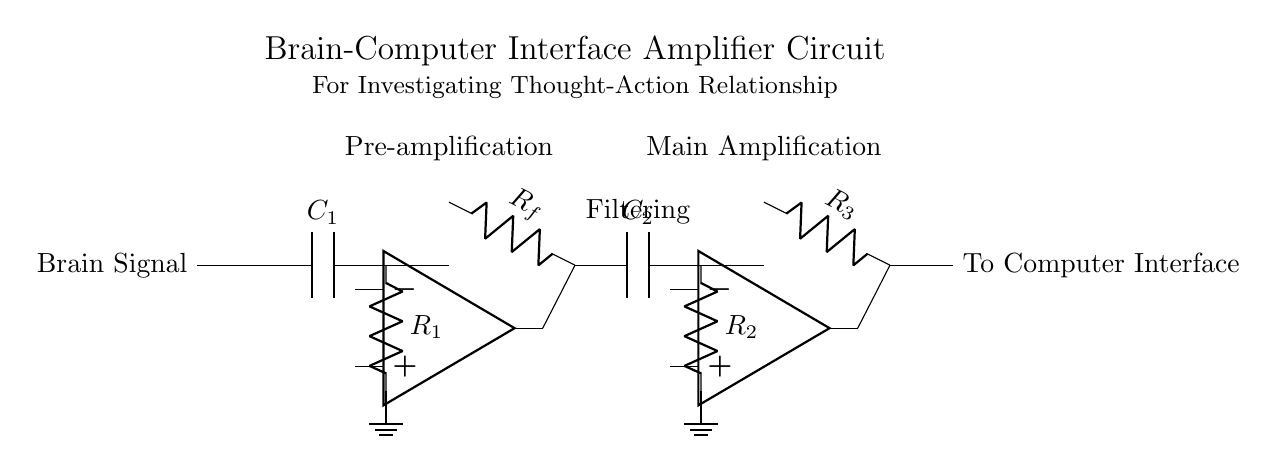What is the first component in the circuit? The first component linked to the brain signal input in the circuit is a capacitor labeled C1. It is the component that initially receives the brain signal.
Answer: Capacitor C1 How many operational amplifiers are in this circuit? There are two operational amplifiers present in this circuit, denoted as op amp 1 and op amp 2. Each is located after a stage of amplification.
Answer: Two What is the function of capacitor C2? Capacitor C2 is used in the filtering stage of the circuit, which helps remove unwanted frequencies from the signal before amplification. This improves the signal quality.
Answer: Filtering What roles do resistors R1, R2, and R3 play? Resistors R1, R2, and R3 function as feedback and load resistors in the amplifier stages, influencing gain and stability, and together they help set the output level of the amplified signal.
Answer: Gain control What is the label indicating the output of the circuit? The output of the circuit is labeled "To Computer Interface," which indicates that the amplified signal is directed towards an interface for further processing or analysis.
Answer: To Computer Interface What stage follows pre-amplification in this circuit? The stage that follows pre-amplification is the filtering stage, which is designed to clean up the signal by removing noise before it goes into the main amplification stage.
Answer: Filtering What is the primary purpose of this circuit? The primary purpose of this amplifier circuit is to investigate the relationship between thought and physical action by enhancing brain signals for analysis by the computer interface.
Answer: Investigate thought-action relationship 